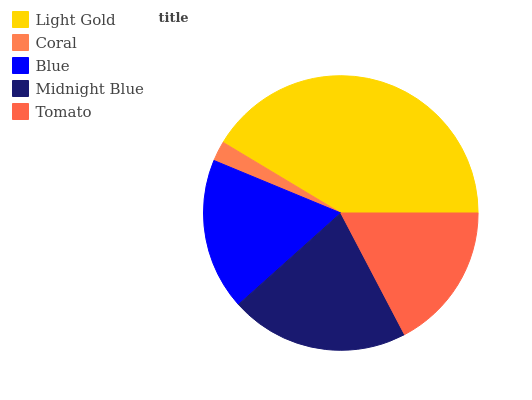Is Coral the minimum?
Answer yes or no. Yes. Is Light Gold the maximum?
Answer yes or no. Yes. Is Blue the minimum?
Answer yes or no. No. Is Blue the maximum?
Answer yes or no. No. Is Blue greater than Coral?
Answer yes or no. Yes. Is Coral less than Blue?
Answer yes or no. Yes. Is Coral greater than Blue?
Answer yes or no. No. Is Blue less than Coral?
Answer yes or no. No. Is Blue the high median?
Answer yes or no. Yes. Is Blue the low median?
Answer yes or no. Yes. Is Midnight Blue the high median?
Answer yes or no. No. Is Midnight Blue the low median?
Answer yes or no. No. 